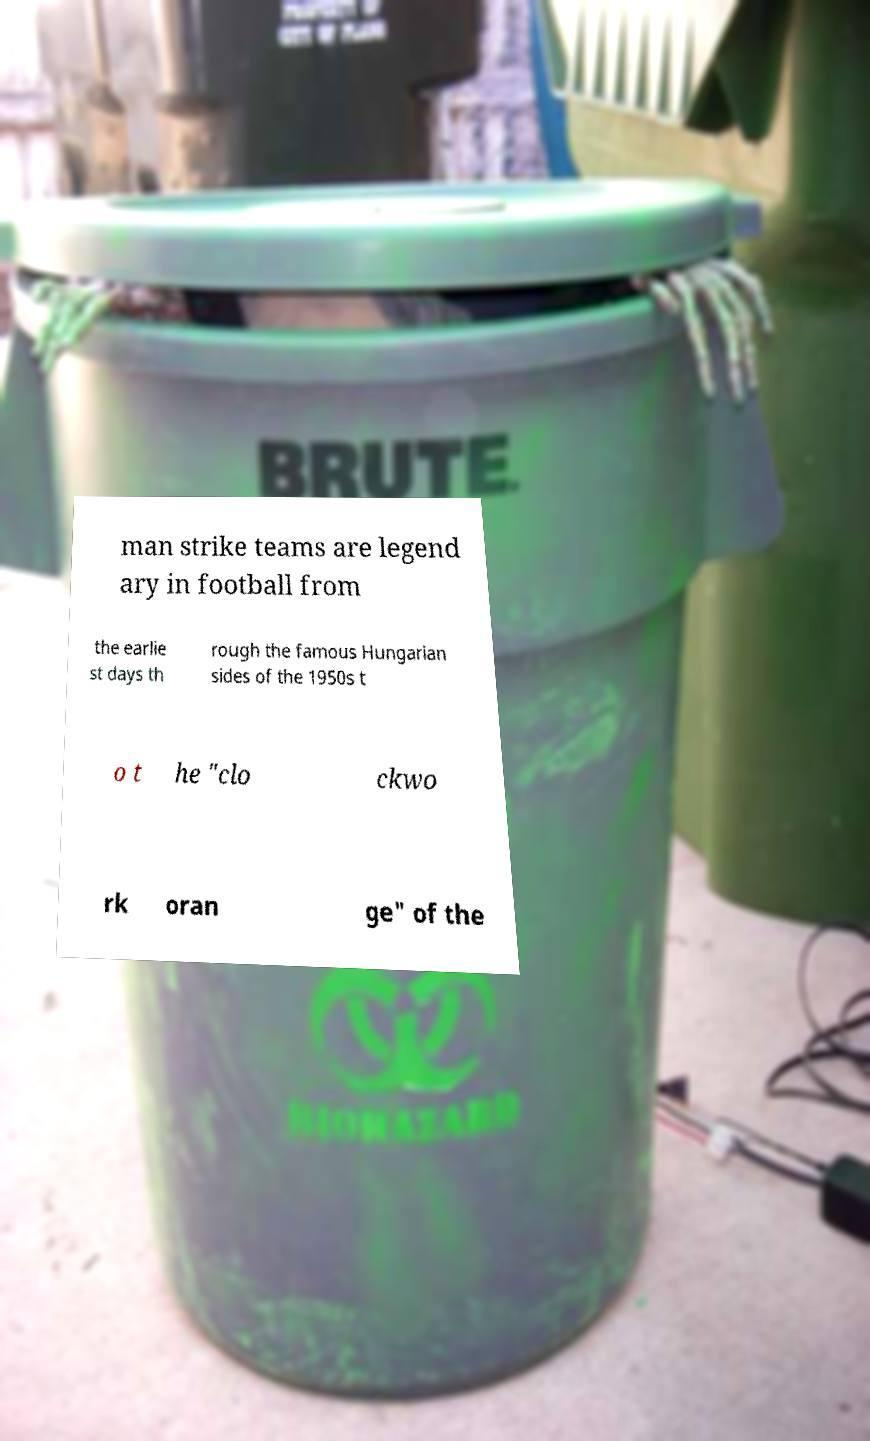What messages or text are displayed in this image? I need them in a readable, typed format. man strike teams are legend ary in football from the earlie st days th rough the famous Hungarian sides of the 1950s t o t he "clo ckwo rk oran ge" of the 